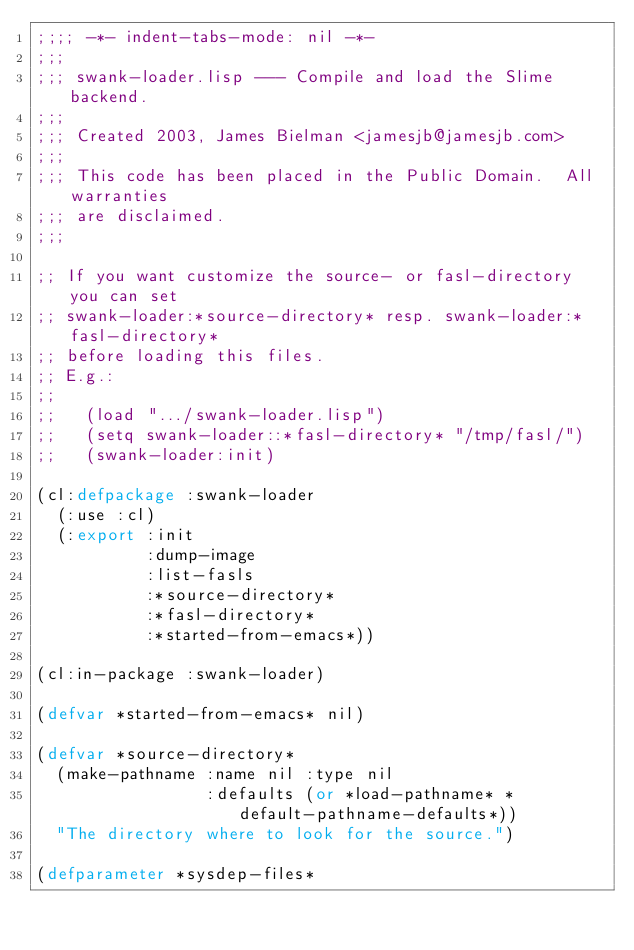<code> <loc_0><loc_0><loc_500><loc_500><_Lisp_>;;;; -*- indent-tabs-mode: nil -*-
;;;
;;; swank-loader.lisp --- Compile and load the Slime backend.
;;;
;;; Created 2003, James Bielman <jamesjb@jamesjb.com>
;;;
;;; This code has been placed in the Public Domain.  All warranties
;;; are disclaimed.
;;;

;; If you want customize the source- or fasl-directory you can set
;; swank-loader:*source-directory* resp. swank-loader:*fasl-directory*
;; before loading this files.
;; E.g.:
;;
;;   (load ".../swank-loader.lisp")
;;   (setq swank-loader::*fasl-directory* "/tmp/fasl/")
;;   (swank-loader:init)

(cl:defpackage :swank-loader
  (:use :cl)
  (:export :init
           :dump-image
           :list-fasls
           :*source-directory*
           :*fasl-directory*
           :*started-from-emacs*))

(cl:in-package :swank-loader)

(defvar *started-from-emacs* nil)

(defvar *source-directory*
  (make-pathname :name nil :type nil
                 :defaults (or *load-pathname* *default-pathname-defaults*))
  "The directory where to look for the source.")

(defparameter *sysdep-files*</code> 